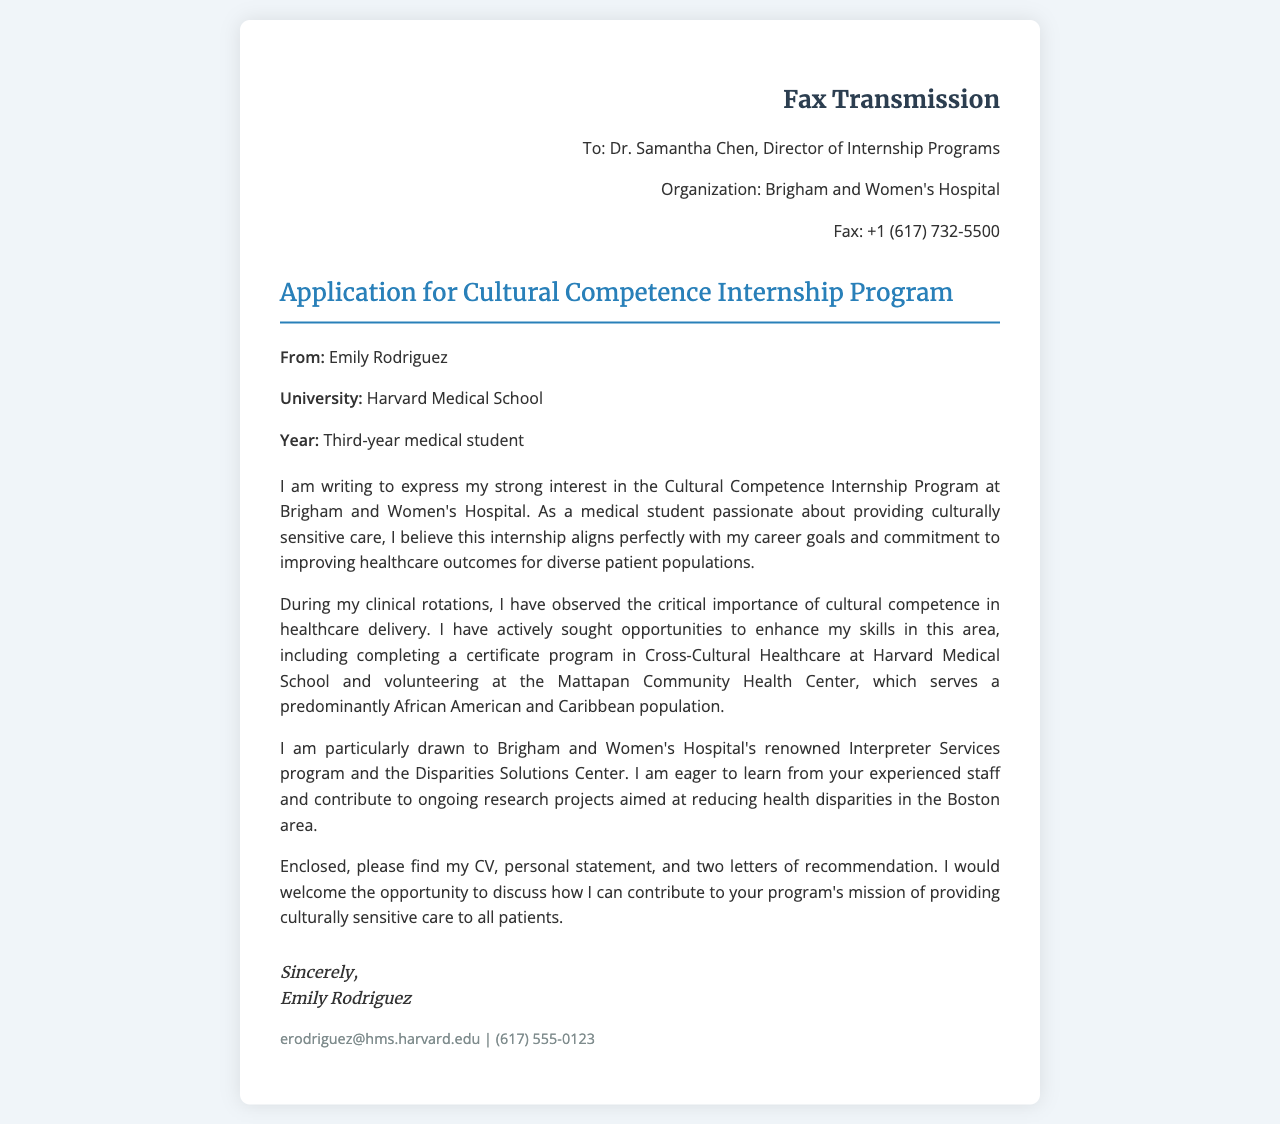What is the name of the applicant? The applicant's name is mentioned at the beginning of the document as "Emily Rodriguez."
Answer: Emily Rodriguez Who is the recipient of the fax? The fax is addressed to Dr. Samantha Chen, who is the Director of Internship Programs.
Answer: Dr. Samantha Chen What is the internship program's focus? The document specifies that the internship program focuses on cultural competence and sensitive care.
Answer: Cultural Competence Where is the applicant studying? The applicant's university is stated as Harvard Medical School in the document.
Answer: Harvard Medical School What program is the applicant particularly interested in at Brigham and Women's Hospital? The applicant is drawn to the Interpreter Services program and the Disparities Solutions Center.
Answer: Interpreter Services program and the Disparities Solutions Center What is enclosed with the fax? The applicant mentions enclosing their CV, personal statement, and two letters of recommendation with the fax.
Answer: CV, personal statement, and two letters of recommendation What year is the applicant in their medical education? The document indicates that the applicant is a third-year medical student.
Answer: Third-year What is the contact email provided by the applicant? The applicant includes their email address for contact purposes, which is formatted in the document.
Answer: erodriguez@hms.harvard.edu What kind of experience does the applicant highlight in the document? The applicant highlights their experience volunteering at Mattapan Community Health Center and completing a certificate program in Cross-Cultural Healthcare.
Answer: Volunteering and completing a certificate program 